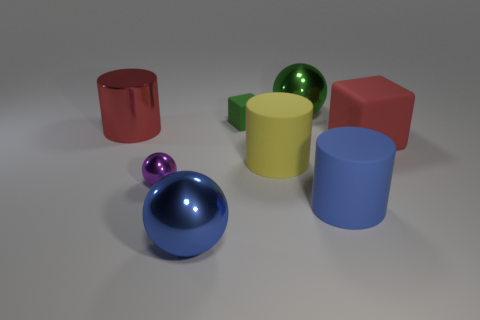Add 2 big blocks. How many objects exist? 10 Subtract all blocks. How many objects are left? 6 Add 5 big shiny objects. How many big shiny objects are left? 8 Add 8 tiny green things. How many tiny green things exist? 9 Subtract 1 purple spheres. How many objects are left? 7 Subtract all small rubber things. Subtract all small shiny spheres. How many objects are left? 6 